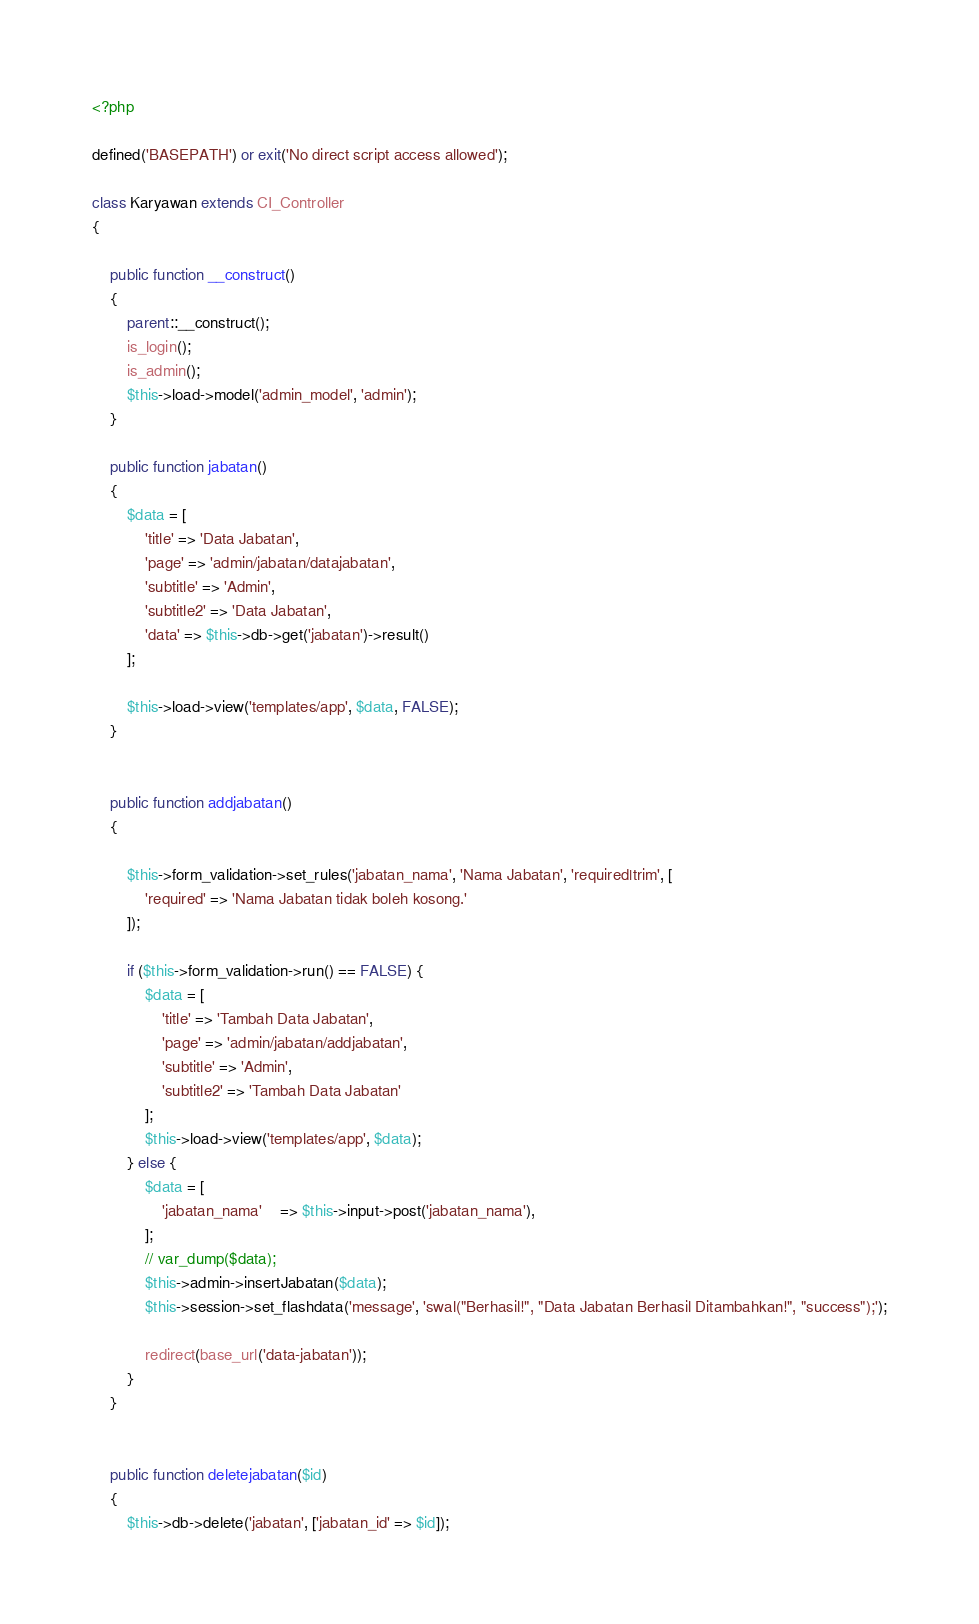Convert code to text. <code><loc_0><loc_0><loc_500><loc_500><_PHP_><?php

defined('BASEPATH') or exit('No direct script access allowed');

class Karyawan extends CI_Controller
{

	public function __construct()
	{
		parent::__construct();
		is_login();
		is_admin();
		$this->load->model('admin_model', 'admin');
	}

	public function jabatan()
	{
		$data = [
			'title' => 'Data Jabatan',
			'page' => 'admin/jabatan/datajabatan',
			'subtitle' => 'Admin',
			'subtitle2' => 'Data Jabatan',
			'data' => $this->db->get('jabatan')->result()
		];

		$this->load->view('templates/app', $data, FALSE);
	}


	public function addjabatan()
	{

		$this->form_validation->set_rules('jabatan_nama', 'Nama Jabatan', 'required|trim', [
			'required' => 'Nama Jabatan tidak boleh kosong.'
		]);

		if ($this->form_validation->run() == FALSE) {
			$data = [
				'title' => 'Tambah Data Jabatan',
				'page' => 'admin/jabatan/addjabatan',
				'subtitle' => 'Admin',
				'subtitle2' => 'Tambah Data Jabatan'
			];
			$this->load->view('templates/app', $data);
		} else {
			$data = [
				'jabatan_nama' 	=> $this->input->post('jabatan_nama'),
			];
			// var_dump($data);
			$this->admin->insertJabatan($data);
			$this->session->set_flashdata('message', 'swal("Berhasil!", "Data Jabatan Berhasil Ditambahkan!", "success");');

			redirect(base_url('data-jabatan'));
		}
	}


	public function deletejabatan($id)
	{
		$this->db->delete('jabatan', ['jabatan_id' => $id]);</code> 